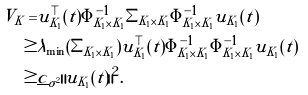Convert formula to latex. <formula><loc_0><loc_0><loc_500><loc_500>V _ { K } = & u _ { K _ { 1 } } ^ { \top } ( t ) \Phi _ { K _ { 1 } \times K _ { 1 } } ^ { - 1 } \Sigma _ { K _ { 1 } \times K _ { 1 } } \Phi _ { K _ { 1 } \times K _ { 1 } } ^ { - 1 } u _ { K _ { 1 } } ( t ) \\ \geq & \lambda _ { \min } ( \Sigma _ { K _ { 1 } \times K _ { 1 } } ) u _ { K _ { 1 } } ^ { \top } ( t ) \Phi _ { K _ { 1 } \times K _ { 1 } } ^ { - 1 } \Phi _ { K _ { 1 } \times K _ { 1 } } ^ { - 1 } u _ { K _ { 1 } } ( t ) \\ \geq & \underline { c } _ { \sigma ^ { 2 } } \| u _ { K _ { 1 } } ( t ) \| ^ { 2 } .</formula> 